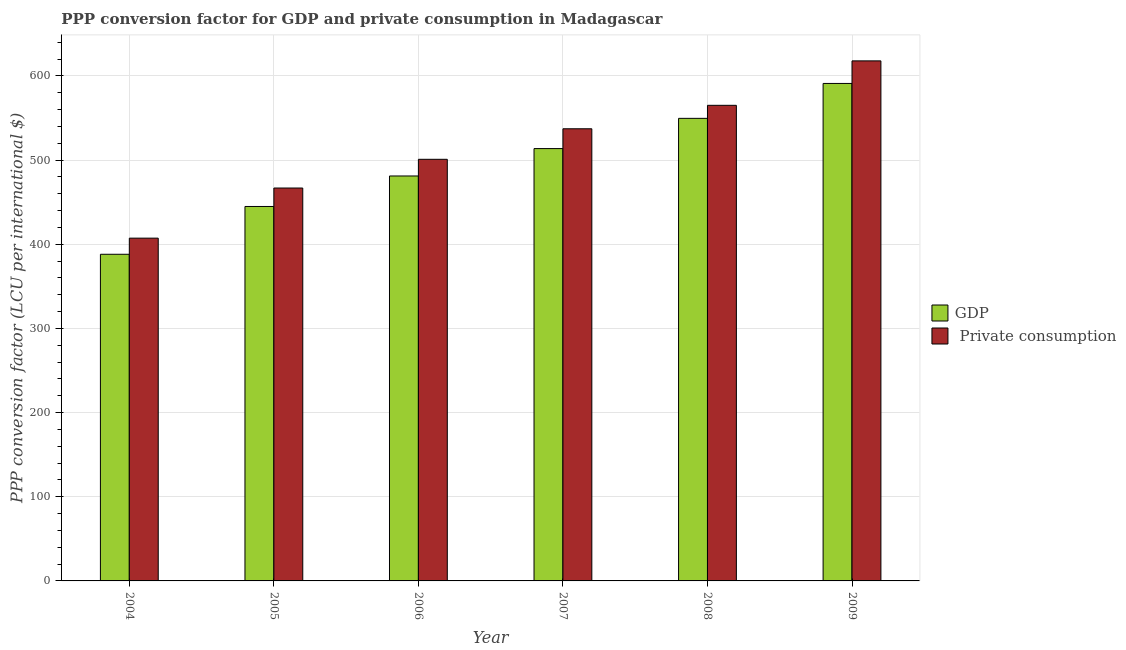Are the number of bars on each tick of the X-axis equal?
Your answer should be very brief. Yes. How many bars are there on the 6th tick from the left?
Your answer should be very brief. 2. How many bars are there on the 4th tick from the right?
Keep it short and to the point. 2. What is the label of the 4th group of bars from the left?
Provide a short and direct response. 2007. What is the ppp conversion factor for private consumption in 2007?
Provide a short and direct response. 537.27. Across all years, what is the maximum ppp conversion factor for private consumption?
Keep it short and to the point. 617.94. Across all years, what is the minimum ppp conversion factor for private consumption?
Keep it short and to the point. 407.3. In which year was the ppp conversion factor for gdp maximum?
Your answer should be compact. 2009. What is the total ppp conversion factor for private consumption in the graph?
Offer a very short reply. 3095.47. What is the difference between the ppp conversion factor for private consumption in 2005 and that in 2009?
Offer a terse response. -151.08. What is the difference between the ppp conversion factor for gdp in 2005 and the ppp conversion factor for private consumption in 2007?
Give a very brief answer. -68.79. What is the average ppp conversion factor for gdp per year?
Provide a short and direct response. 494.79. In the year 2006, what is the difference between the ppp conversion factor for gdp and ppp conversion factor for private consumption?
Offer a terse response. 0. What is the ratio of the ppp conversion factor for gdp in 2006 to that in 2007?
Your answer should be compact. 0.94. Is the difference between the ppp conversion factor for gdp in 2005 and 2008 greater than the difference between the ppp conversion factor for private consumption in 2005 and 2008?
Offer a terse response. No. What is the difference between the highest and the second highest ppp conversion factor for gdp?
Your response must be concise. 41.48. What is the difference between the highest and the lowest ppp conversion factor for private consumption?
Offer a very short reply. 210.64. In how many years, is the ppp conversion factor for gdp greater than the average ppp conversion factor for gdp taken over all years?
Provide a short and direct response. 3. Is the sum of the ppp conversion factor for gdp in 2006 and 2009 greater than the maximum ppp conversion factor for private consumption across all years?
Provide a short and direct response. Yes. What does the 1st bar from the left in 2004 represents?
Provide a succinct answer. GDP. What does the 2nd bar from the right in 2004 represents?
Your answer should be very brief. GDP. How many bars are there?
Give a very brief answer. 12. Are the values on the major ticks of Y-axis written in scientific E-notation?
Provide a succinct answer. No. How many legend labels are there?
Your response must be concise. 2. How are the legend labels stacked?
Your answer should be very brief. Vertical. What is the title of the graph?
Offer a terse response. PPP conversion factor for GDP and private consumption in Madagascar. Does "Research and Development" appear as one of the legend labels in the graph?
Provide a short and direct response. No. What is the label or title of the X-axis?
Offer a very short reply. Year. What is the label or title of the Y-axis?
Keep it short and to the point. PPP conversion factor (LCU per international $). What is the PPP conversion factor (LCU per international $) in GDP in 2004?
Offer a very short reply. 388.14. What is the PPP conversion factor (LCU per international $) in  Private consumption in 2004?
Provide a short and direct response. 407.3. What is the PPP conversion factor (LCU per international $) of GDP in 2005?
Offer a very short reply. 444.93. What is the PPP conversion factor (LCU per international $) of  Private consumption in 2005?
Your response must be concise. 466.86. What is the PPP conversion factor (LCU per international $) in GDP in 2006?
Make the answer very short. 481.18. What is the PPP conversion factor (LCU per international $) in  Private consumption in 2006?
Offer a very short reply. 500.99. What is the PPP conversion factor (LCU per international $) of GDP in 2007?
Ensure brevity in your answer.  513.72. What is the PPP conversion factor (LCU per international $) of  Private consumption in 2007?
Your answer should be very brief. 537.27. What is the PPP conversion factor (LCU per international $) in GDP in 2008?
Your answer should be very brief. 549.65. What is the PPP conversion factor (LCU per international $) of  Private consumption in 2008?
Ensure brevity in your answer.  565.12. What is the PPP conversion factor (LCU per international $) in GDP in 2009?
Your answer should be compact. 591.12. What is the PPP conversion factor (LCU per international $) in  Private consumption in 2009?
Provide a short and direct response. 617.94. Across all years, what is the maximum PPP conversion factor (LCU per international $) of GDP?
Your response must be concise. 591.12. Across all years, what is the maximum PPP conversion factor (LCU per international $) of  Private consumption?
Give a very brief answer. 617.94. Across all years, what is the minimum PPP conversion factor (LCU per international $) of GDP?
Make the answer very short. 388.14. Across all years, what is the minimum PPP conversion factor (LCU per international $) in  Private consumption?
Ensure brevity in your answer.  407.3. What is the total PPP conversion factor (LCU per international $) of GDP in the graph?
Make the answer very short. 2968.75. What is the total PPP conversion factor (LCU per international $) of  Private consumption in the graph?
Provide a short and direct response. 3095.47. What is the difference between the PPP conversion factor (LCU per international $) of GDP in 2004 and that in 2005?
Your answer should be very brief. -56.79. What is the difference between the PPP conversion factor (LCU per international $) of  Private consumption in 2004 and that in 2005?
Provide a succinct answer. -59.56. What is the difference between the PPP conversion factor (LCU per international $) in GDP in 2004 and that in 2006?
Your answer should be compact. -93.04. What is the difference between the PPP conversion factor (LCU per international $) in  Private consumption in 2004 and that in 2006?
Provide a short and direct response. -93.69. What is the difference between the PPP conversion factor (LCU per international $) of GDP in 2004 and that in 2007?
Provide a succinct answer. -125.58. What is the difference between the PPP conversion factor (LCU per international $) of  Private consumption in 2004 and that in 2007?
Ensure brevity in your answer.  -129.97. What is the difference between the PPP conversion factor (LCU per international $) in GDP in 2004 and that in 2008?
Offer a terse response. -161.51. What is the difference between the PPP conversion factor (LCU per international $) in  Private consumption in 2004 and that in 2008?
Provide a succinct answer. -157.83. What is the difference between the PPP conversion factor (LCU per international $) in GDP in 2004 and that in 2009?
Provide a succinct answer. -202.98. What is the difference between the PPP conversion factor (LCU per international $) in  Private consumption in 2004 and that in 2009?
Give a very brief answer. -210.64. What is the difference between the PPP conversion factor (LCU per international $) of GDP in 2005 and that in 2006?
Offer a very short reply. -36.25. What is the difference between the PPP conversion factor (LCU per international $) in  Private consumption in 2005 and that in 2006?
Your answer should be compact. -34.13. What is the difference between the PPP conversion factor (LCU per international $) of GDP in 2005 and that in 2007?
Ensure brevity in your answer.  -68.79. What is the difference between the PPP conversion factor (LCU per international $) in  Private consumption in 2005 and that in 2007?
Your answer should be very brief. -70.41. What is the difference between the PPP conversion factor (LCU per international $) in GDP in 2005 and that in 2008?
Your response must be concise. -104.72. What is the difference between the PPP conversion factor (LCU per international $) in  Private consumption in 2005 and that in 2008?
Keep it short and to the point. -98.27. What is the difference between the PPP conversion factor (LCU per international $) of GDP in 2005 and that in 2009?
Keep it short and to the point. -146.19. What is the difference between the PPP conversion factor (LCU per international $) of  Private consumption in 2005 and that in 2009?
Your answer should be compact. -151.08. What is the difference between the PPP conversion factor (LCU per international $) of GDP in 2006 and that in 2007?
Give a very brief answer. -32.54. What is the difference between the PPP conversion factor (LCU per international $) of  Private consumption in 2006 and that in 2007?
Your response must be concise. -36.28. What is the difference between the PPP conversion factor (LCU per international $) in GDP in 2006 and that in 2008?
Offer a terse response. -68.47. What is the difference between the PPP conversion factor (LCU per international $) in  Private consumption in 2006 and that in 2008?
Offer a terse response. -64.14. What is the difference between the PPP conversion factor (LCU per international $) of GDP in 2006 and that in 2009?
Keep it short and to the point. -109.94. What is the difference between the PPP conversion factor (LCU per international $) in  Private consumption in 2006 and that in 2009?
Offer a terse response. -116.95. What is the difference between the PPP conversion factor (LCU per international $) in GDP in 2007 and that in 2008?
Make the answer very short. -35.93. What is the difference between the PPP conversion factor (LCU per international $) in  Private consumption in 2007 and that in 2008?
Give a very brief answer. -27.86. What is the difference between the PPP conversion factor (LCU per international $) in GDP in 2007 and that in 2009?
Your answer should be compact. -77.41. What is the difference between the PPP conversion factor (LCU per international $) in  Private consumption in 2007 and that in 2009?
Offer a terse response. -80.67. What is the difference between the PPP conversion factor (LCU per international $) of GDP in 2008 and that in 2009?
Provide a succinct answer. -41.48. What is the difference between the PPP conversion factor (LCU per international $) in  Private consumption in 2008 and that in 2009?
Keep it short and to the point. -52.81. What is the difference between the PPP conversion factor (LCU per international $) of GDP in 2004 and the PPP conversion factor (LCU per international $) of  Private consumption in 2005?
Provide a short and direct response. -78.72. What is the difference between the PPP conversion factor (LCU per international $) in GDP in 2004 and the PPP conversion factor (LCU per international $) in  Private consumption in 2006?
Offer a terse response. -112.84. What is the difference between the PPP conversion factor (LCU per international $) in GDP in 2004 and the PPP conversion factor (LCU per international $) in  Private consumption in 2007?
Offer a very short reply. -149.12. What is the difference between the PPP conversion factor (LCU per international $) of GDP in 2004 and the PPP conversion factor (LCU per international $) of  Private consumption in 2008?
Your answer should be compact. -176.98. What is the difference between the PPP conversion factor (LCU per international $) of GDP in 2004 and the PPP conversion factor (LCU per international $) of  Private consumption in 2009?
Provide a short and direct response. -229.8. What is the difference between the PPP conversion factor (LCU per international $) in GDP in 2005 and the PPP conversion factor (LCU per international $) in  Private consumption in 2006?
Provide a short and direct response. -56.05. What is the difference between the PPP conversion factor (LCU per international $) in GDP in 2005 and the PPP conversion factor (LCU per international $) in  Private consumption in 2007?
Provide a short and direct response. -92.33. What is the difference between the PPP conversion factor (LCU per international $) in GDP in 2005 and the PPP conversion factor (LCU per international $) in  Private consumption in 2008?
Your answer should be very brief. -120.19. What is the difference between the PPP conversion factor (LCU per international $) of GDP in 2005 and the PPP conversion factor (LCU per international $) of  Private consumption in 2009?
Offer a very short reply. -173.01. What is the difference between the PPP conversion factor (LCU per international $) of GDP in 2006 and the PPP conversion factor (LCU per international $) of  Private consumption in 2007?
Make the answer very short. -56.08. What is the difference between the PPP conversion factor (LCU per international $) of GDP in 2006 and the PPP conversion factor (LCU per international $) of  Private consumption in 2008?
Keep it short and to the point. -83.94. What is the difference between the PPP conversion factor (LCU per international $) in GDP in 2006 and the PPP conversion factor (LCU per international $) in  Private consumption in 2009?
Make the answer very short. -136.76. What is the difference between the PPP conversion factor (LCU per international $) of GDP in 2007 and the PPP conversion factor (LCU per international $) of  Private consumption in 2008?
Ensure brevity in your answer.  -51.41. What is the difference between the PPP conversion factor (LCU per international $) in GDP in 2007 and the PPP conversion factor (LCU per international $) in  Private consumption in 2009?
Provide a succinct answer. -104.22. What is the difference between the PPP conversion factor (LCU per international $) of GDP in 2008 and the PPP conversion factor (LCU per international $) of  Private consumption in 2009?
Your answer should be compact. -68.29. What is the average PPP conversion factor (LCU per international $) of GDP per year?
Your response must be concise. 494.79. What is the average PPP conversion factor (LCU per international $) of  Private consumption per year?
Offer a very short reply. 515.91. In the year 2004, what is the difference between the PPP conversion factor (LCU per international $) of GDP and PPP conversion factor (LCU per international $) of  Private consumption?
Offer a very short reply. -19.15. In the year 2005, what is the difference between the PPP conversion factor (LCU per international $) of GDP and PPP conversion factor (LCU per international $) of  Private consumption?
Make the answer very short. -21.92. In the year 2006, what is the difference between the PPP conversion factor (LCU per international $) of GDP and PPP conversion factor (LCU per international $) of  Private consumption?
Ensure brevity in your answer.  -19.8. In the year 2007, what is the difference between the PPP conversion factor (LCU per international $) of GDP and PPP conversion factor (LCU per international $) of  Private consumption?
Give a very brief answer. -23.55. In the year 2008, what is the difference between the PPP conversion factor (LCU per international $) in GDP and PPP conversion factor (LCU per international $) in  Private consumption?
Your answer should be compact. -15.48. In the year 2009, what is the difference between the PPP conversion factor (LCU per international $) in GDP and PPP conversion factor (LCU per international $) in  Private consumption?
Offer a terse response. -26.81. What is the ratio of the PPP conversion factor (LCU per international $) of GDP in 2004 to that in 2005?
Your answer should be very brief. 0.87. What is the ratio of the PPP conversion factor (LCU per international $) of  Private consumption in 2004 to that in 2005?
Ensure brevity in your answer.  0.87. What is the ratio of the PPP conversion factor (LCU per international $) of GDP in 2004 to that in 2006?
Your answer should be compact. 0.81. What is the ratio of the PPP conversion factor (LCU per international $) of  Private consumption in 2004 to that in 2006?
Your response must be concise. 0.81. What is the ratio of the PPP conversion factor (LCU per international $) in GDP in 2004 to that in 2007?
Offer a terse response. 0.76. What is the ratio of the PPP conversion factor (LCU per international $) in  Private consumption in 2004 to that in 2007?
Provide a succinct answer. 0.76. What is the ratio of the PPP conversion factor (LCU per international $) in GDP in 2004 to that in 2008?
Your response must be concise. 0.71. What is the ratio of the PPP conversion factor (LCU per international $) of  Private consumption in 2004 to that in 2008?
Provide a succinct answer. 0.72. What is the ratio of the PPP conversion factor (LCU per international $) in GDP in 2004 to that in 2009?
Offer a very short reply. 0.66. What is the ratio of the PPP conversion factor (LCU per international $) in  Private consumption in 2004 to that in 2009?
Your answer should be very brief. 0.66. What is the ratio of the PPP conversion factor (LCU per international $) in GDP in 2005 to that in 2006?
Provide a succinct answer. 0.92. What is the ratio of the PPP conversion factor (LCU per international $) of  Private consumption in 2005 to that in 2006?
Your answer should be compact. 0.93. What is the ratio of the PPP conversion factor (LCU per international $) of GDP in 2005 to that in 2007?
Provide a short and direct response. 0.87. What is the ratio of the PPP conversion factor (LCU per international $) of  Private consumption in 2005 to that in 2007?
Offer a very short reply. 0.87. What is the ratio of the PPP conversion factor (LCU per international $) in GDP in 2005 to that in 2008?
Offer a very short reply. 0.81. What is the ratio of the PPP conversion factor (LCU per international $) in  Private consumption in 2005 to that in 2008?
Your answer should be compact. 0.83. What is the ratio of the PPP conversion factor (LCU per international $) of GDP in 2005 to that in 2009?
Offer a terse response. 0.75. What is the ratio of the PPP conversion factor (LCU per international $) of  Private consumption in 2005 to that in 2009?
Make the answer very short. 0.76. What is the ratio of the PPP conversion factor (LCU per international $) of GDP in 2006 to that in 2007?
Your response must be concise. 0.94. What is the ratio of the PPP conversion factor (LCU per international $) in  Private consumption in 2006 to that in 2007?
Your answer should be very brief. 0.93. What is the ratio of the PPP conversion factor (LCU per international $) of GDP in 2006 to that in 2008?
Your answer should be very brief. 0.88. What is the ratio of the PPP conversion factor (LCU per international $) in  Private consumption in 2006 to that in 2008?
Provide a succinct answer. 0.89. What is the ratio of the PPP conversion factor (LCU per international $) of GDP in 2006 to that in 2009?
Make the answer very short. 0.81. What is the ratio of the PPP conversion factor (LCU per international $) in  Private consumption in 2006 to that in 2009?
Ensure brevity in your answer.  0.81. What is the ratio of the PPP conversion factor (LCU per international $) in GDP in 2007 to that in 2008?
Offer a terse response. 0.93. What is the ratio of the PPP conversion factor (LCU per international $) in  Private consumption in 2007 to that in 2008?
Offer a terse response. 0.95. What is the ratio of the PPP conversion factor (LCU per international $) of GDP in 2007 to that in 2009?
Make the answer very short. 0.87. What is the ratio of the PPP conversion factor (LCU per international $) of  Private consumption in 2007 to that in 2009?
Your response must be concise. 0.87. What is the ratio of the PPP conversion factor (LCU per international $) of GDP in 2008 to that in 2009?
Offer a very short reply. 0.93. What is the ratio of the PPP conversion factor (LCU per international $) of  Private consumption in 2008 to that in 2009?
Offer a very short reply. 0.91. What is the difference between the highest and the second highest PPP conversion factor (LCU per international $) in GDP?
Your answer should be compact. 41.48. What is the difference between the highest and the second highest PPP conversion factor (LCU per international $) in  Private consumption?
Your answer should be compact. 52.81. What is the difference between the highest and the lowest PPP conversion factor (LCU per international $) of GDP?
Provide a succinct answer. 202.98. What is the difference between the highest and the lowest PPP conversion factor (LCU per international $) in  Private consumption?
Keep it short and to the point. 210.64. 